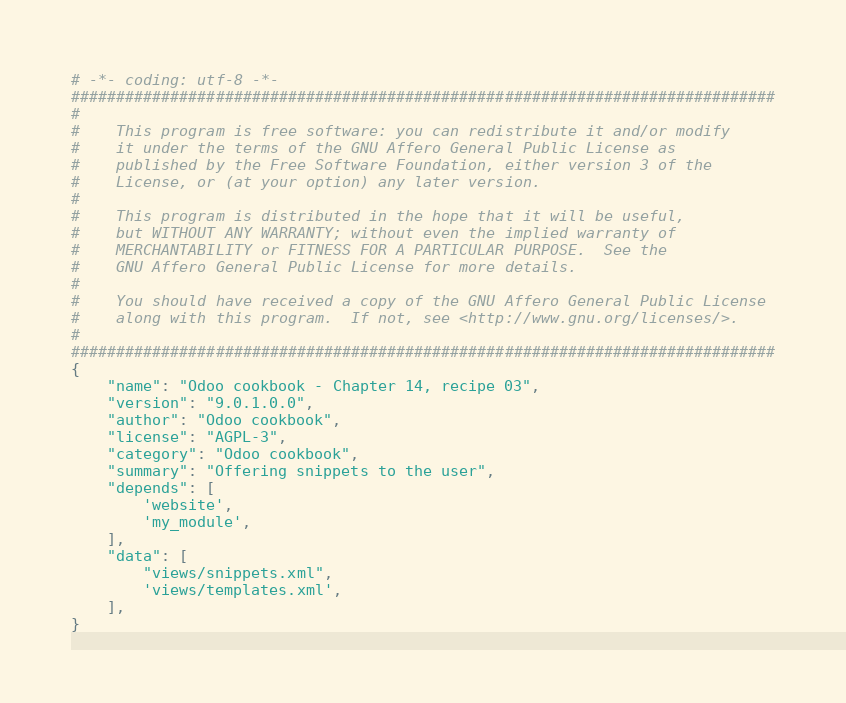<code> <loc_0><loc_0><loc_500><loc_500><_Python_># -*- coding: utf-8 -*-
##############################################################################
#
#    This program is free software: you can redistribute it and/or modify
#    it under the terms of the GNU Affero General Public License as
#    published by the Free Software Foundation, either version 3 of the
#    License, or (at your option) any later version.
#
#    This program is distributed in the hope that it will be useful,
#    but WITHOUT ANY WARRANTY; without even the implied warranty of
#    MERCHANTABILITY or FITNESS FOR A PARTICULAR PURPOSE.  See the
#    GNU Affero General Public License for more details.
#
#    You should have received a copy of the GNU Affero General Public License
#    along with this program.  If not, see <http://www.gnu.org/licenses/>.
#
##############################################################################
{
    "name": "Odoo cookbook - Chapter 14, recipe 03",
    "version": "9.0.1.0.0",
    "author": "Odoo cookbook",
    "license": "AGPL-3",
    "category": "Odoo cookbook",
    "summary": "Offering snippets to the user",
    "depends": [
        'website',
        'my_module',
    ],
    "data": [
        "views/snippets.xml",
        'views/templates.xml',
    ],
}
</code> 